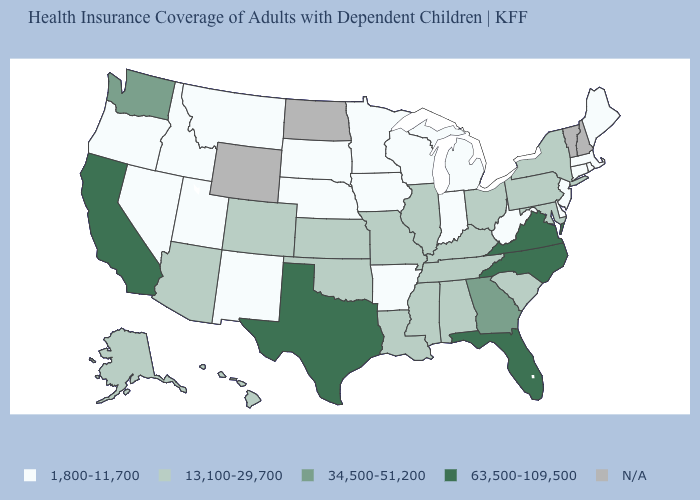Does the map have missing data?
Answer briefly. Yes. What is the value of Maine?
Write a very short answer. 1,800-11,700. Name the states that have a value in the range 13,100-29,700?
Be succinct. Alabama, Alaska, Arizona, Colorado, Hawaii, Illinois, Kansas, Kentucky, Louisiana, Maryland, Mississippi, Missouri, New York, Ohio, Oklahoma, Pennsylvania, South Carolina, Tennessee. Does New Jersey have the lowest value in the USA?
Write a very short answer. Yes. Does the first symbol in the legend represent the smallest category?
Quick response, please. Yes. Among the states that border Virginia , which have the highest value?
Write a very short answer. North Carolina. What is the highest value in the West ?
Be succinct. 63,500-109,500. Does Arkansas have the lowest value in the South?
Concise answer only. Yes. What is the value of Delaware?
Give a very brief answer. 1,800-11,700. Name the states that have a value in the range 13,100-29,700?
Write a very short answer. Alabama, Alaska, Arizona, Colorado, Hawaii, Illinois, Kansas, Kentucky, Louisiana, Maryland, Mississippi, Missouri, New York, Ohio, Oklahoma, Pennsylvania, South Carolina, Tennessee. What is the value of New Hampshire?
Give a very brief answer. N/A. Name the states that have a value in the range 63,500-109,500?
Keep it brief. California, Florida, North Carolina, Texas, Virginia. What is the value of Connecticut?
Answer briefly. 1,800-11,700. What is the value of Kansas?
Write a very short answer. 13,100-29,700. 